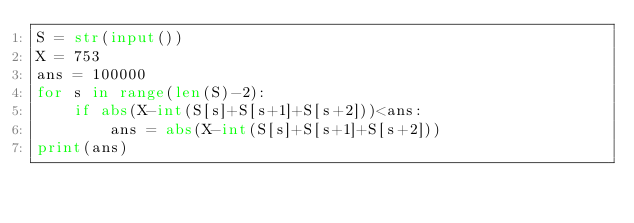<code> <loc_0><loc_0><loc_500><loc_500><_Python_>S = str(input())
X = 753
ans = 100000
for s in range(len(S)-2):
    if abs(X-int(S[s]+S[s+1]+S[s+2]))<ans:
        ans = abs(X-int(S[s]+S[s+1]+S[s+2]))
print(ans)</code> 